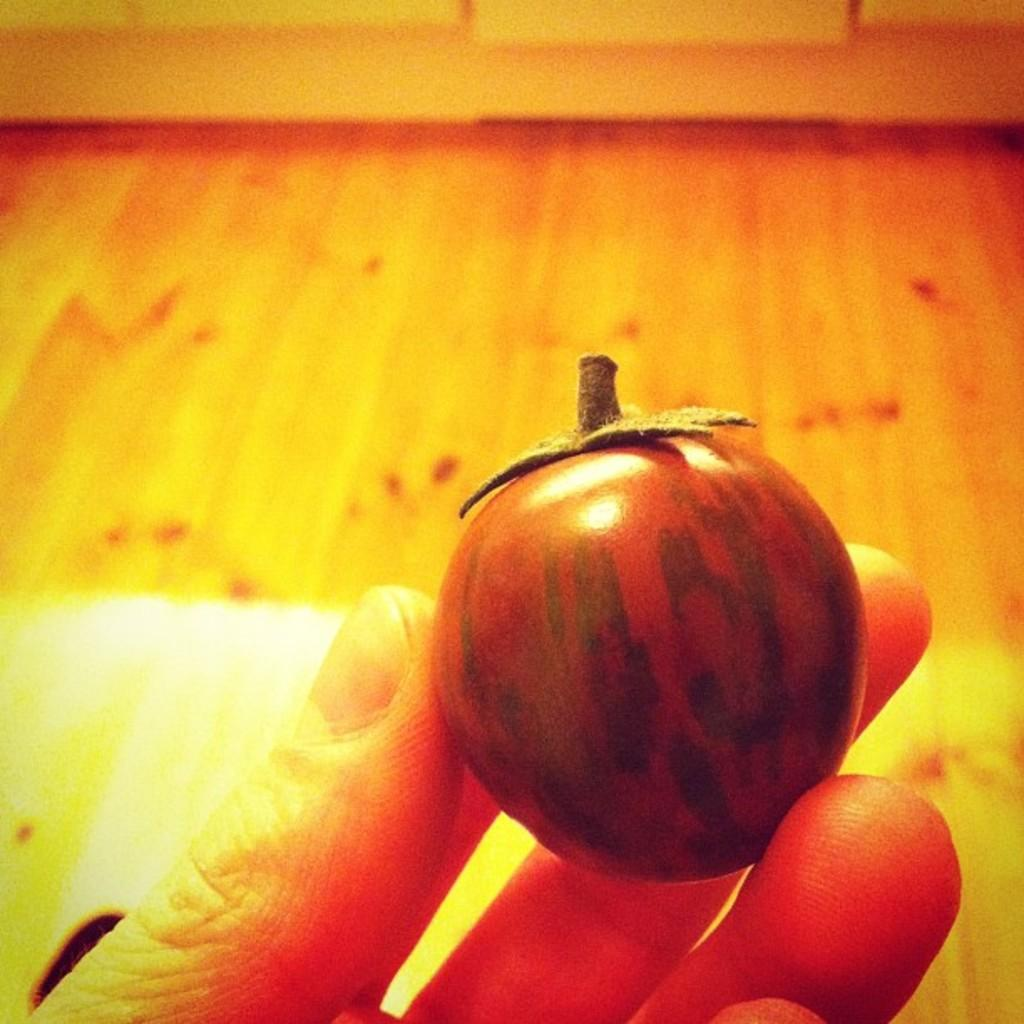What object is being held by someone in the image? There is a vegetable holder in the image, and it is being held by someone. What can be seen below the person holding the vegetable holder? The floor is visible in the image. What type of bead is being used to decorate the vegetable holder in the image? There is no bead present on the vegetable holder in the image. How is the toothpaste being used in the image? There is no toothpaste present in the image. 